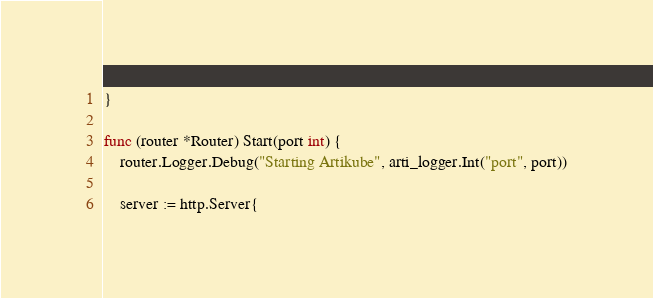Convert code to text. <code><loc_0><loc_0><loc_500><loc_500><_Go_>}

func (router *Router) Start(port int) {
	router.Logger.Debug("Starting Artikube", arti_logger.Int("port", port))

	server := http.Server{</code> 